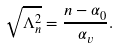<formula> <loc_0><loc_0><loc_500><loc_500>\sqrt { \Lambda _ { n } ^ { 2 } } = \frac { n - \alpha _ { 0 } } { \alpha _ { v } } .</formula> 